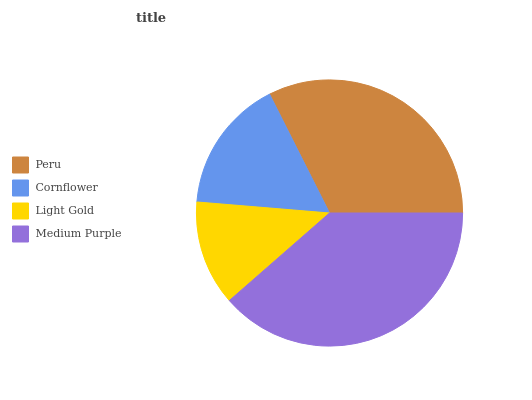Is Light Gold the minimum?
Answer yes or no. Yes. Is Medium Purple the maximum?
Answer yes or no. Yes. Is Cornflower the minimum?
Answer yes or no. No. Is Cornflower the maximum?
Answer yes or no. No. Is Peru greater than Cornflower?
Answer yes or no. Yes. Is Cornflower less than Peru?
Answer yes or no. Yes. Is Cornflower greater than Peru?
Answer yes or no. No. Is Peru less than Cornflower?
Answer yes or no. No. Is Peru the high median?
Answer yes or no. Yes. Is Cornflower the low median?
Answer yes or no. Yes. Is Light Gold the high median?
Answer yes or no. No. Is Peru the low median?
Answer yes or no. No. 